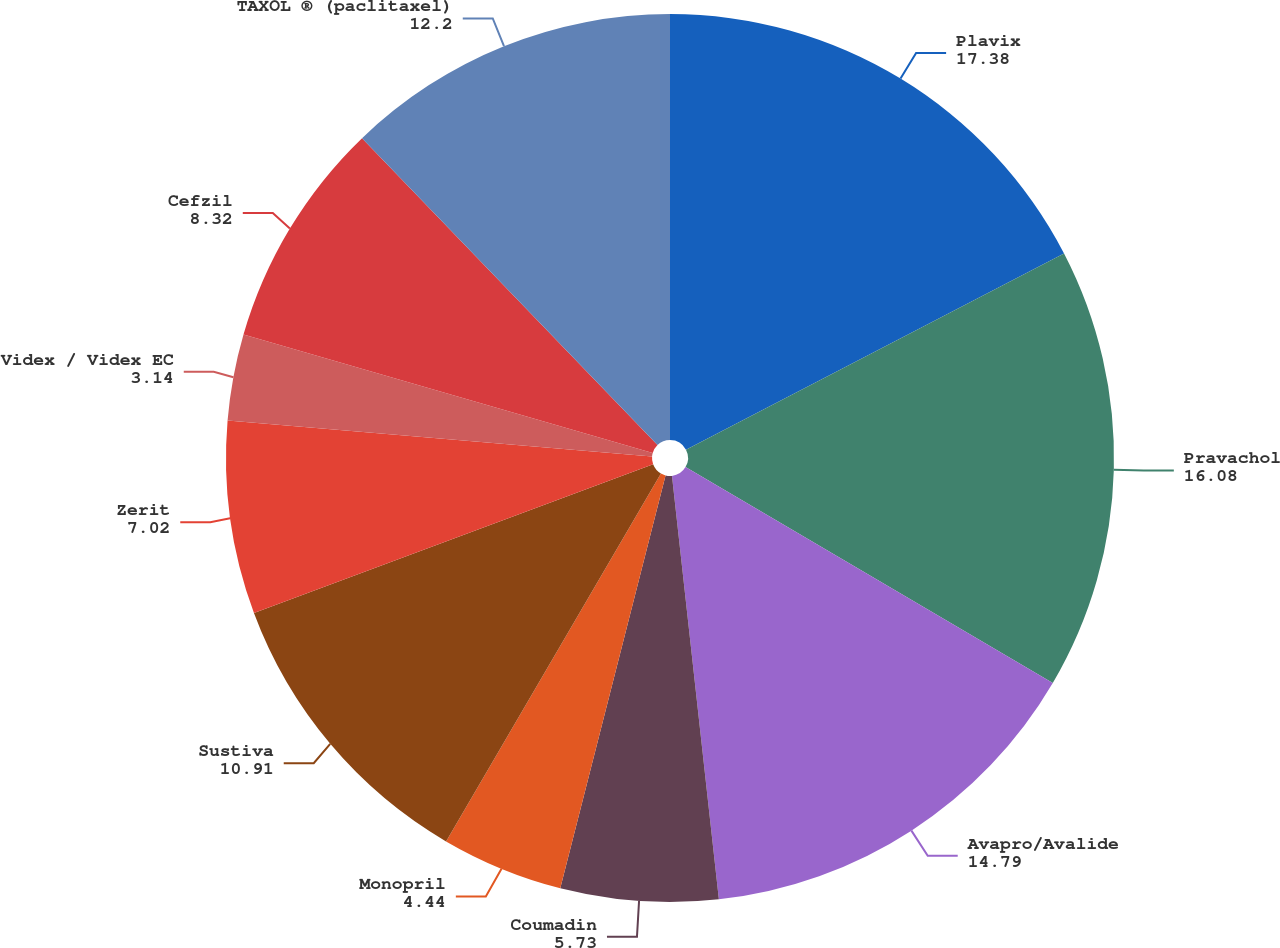Convert chart to OTSL. <chart><loc_0><loc_0><loc_500><loc_500><pie_chart><fcel>Plavix<fcel>Pravachol<fcel>Avapro/Avalide<fcel>Coumadin<fcel>Monopril<fcel>Sustiva<fcel>Zerit<fcel>Videx / Videx EC<fcel>Cefzil<fcel>TAXOL ® (paclitaxel)<nl><fcel>17.38%<fcel>16.08%<fcel>14.79%<fcel>5.73%<fcel>4.44%<fcel>10.91%<fcel>7.02%<fcel>3.14%<fcel>8.32%<fcel>12.2%<nl></chart> 